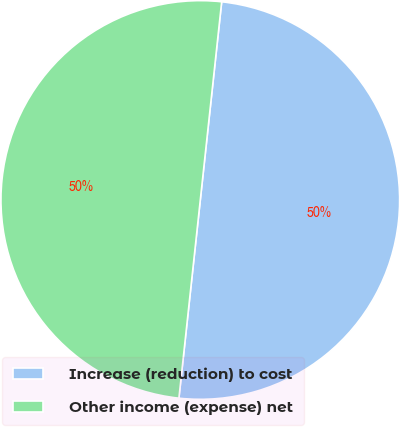<chart> <loc_0><loc_0><loc_500><loc_500><pie_chart><fcel>Increase (reduction) to cost<fcel>Other income (expense) net<nl><fcel>50.0%<fcel>50.0%<nl></chart> 